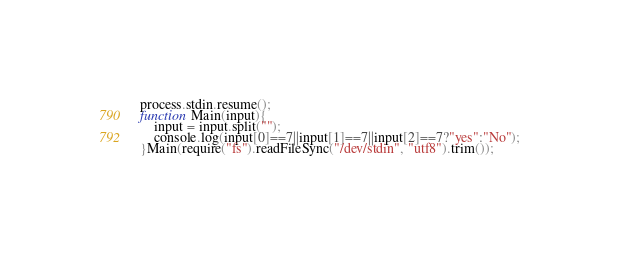Convert code to text. <code><loc_0><loc_0><loc_500><loc_500><_JavaScript_>process.stdin.resume();
function Main(input){
	input = input.split("");
	console.log(input[0]==7||input[1]==7||input[2]==7?"yes":"No");
}Main(require("fs").readFileSync("/dev/stdin", "utf8").trim());</code> 